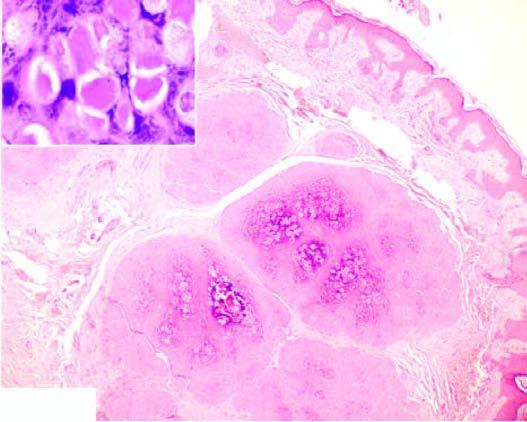do the epidermal layers show numerous molluscum bodies which are intracytoplasmic inclusions?
Answer the question using a single word or phrase. Yes 